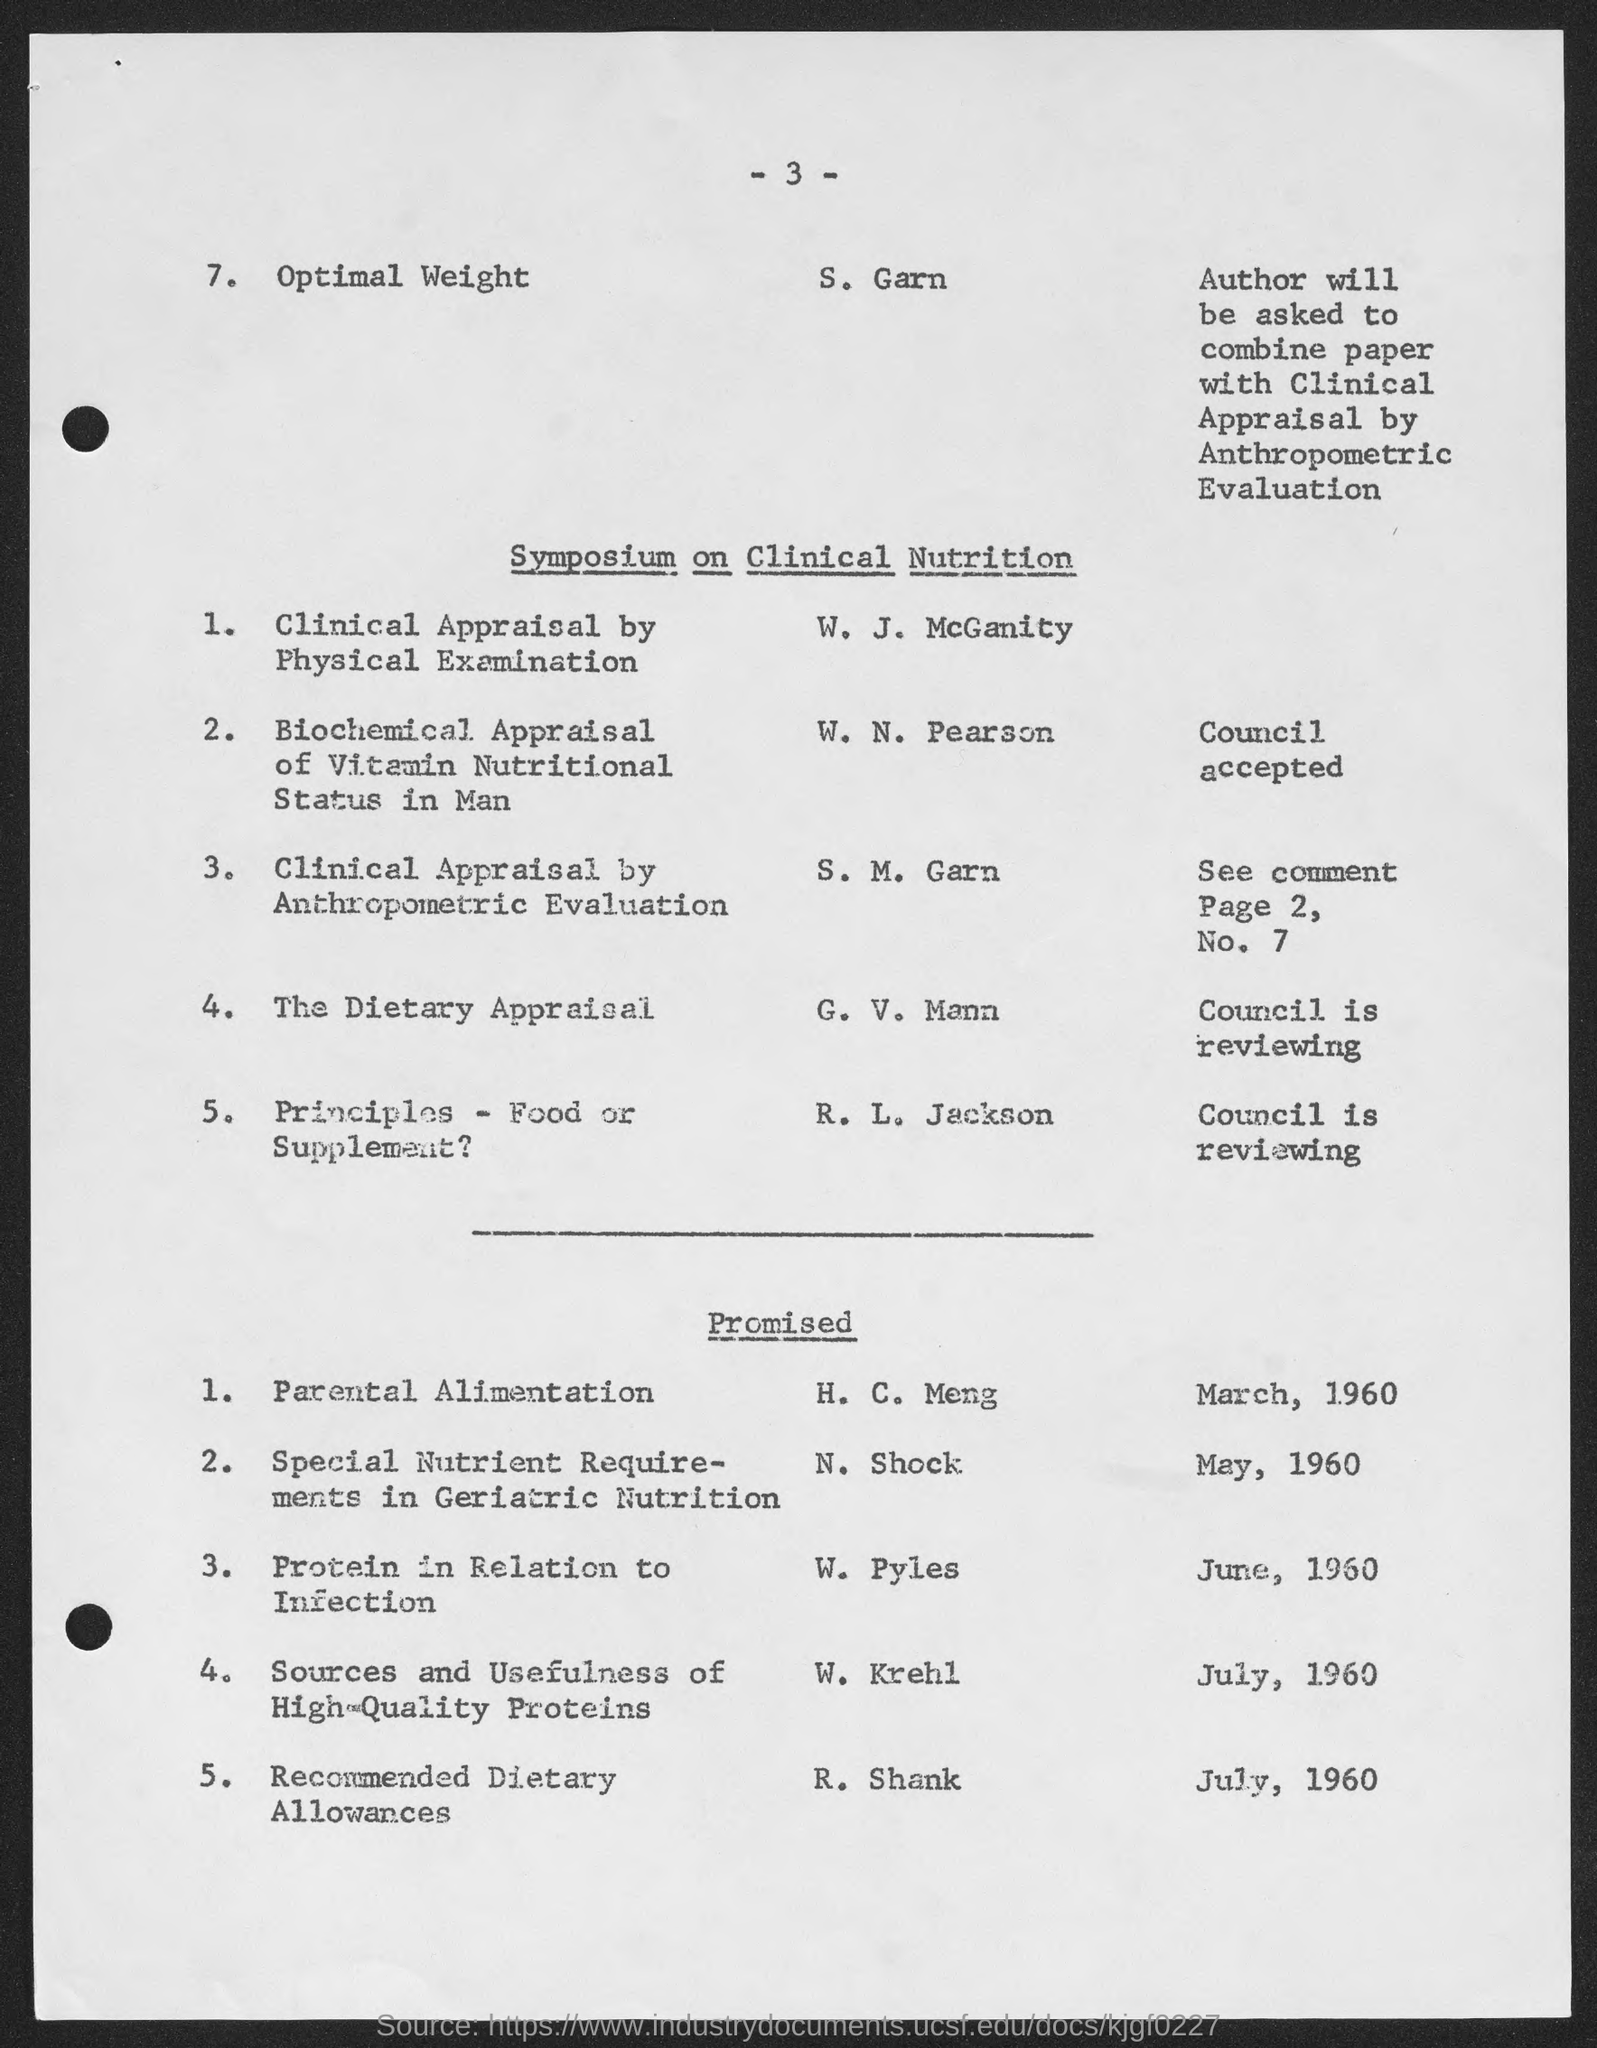What is the number at top of the page ?
Offer a terse response. - 3 -. 